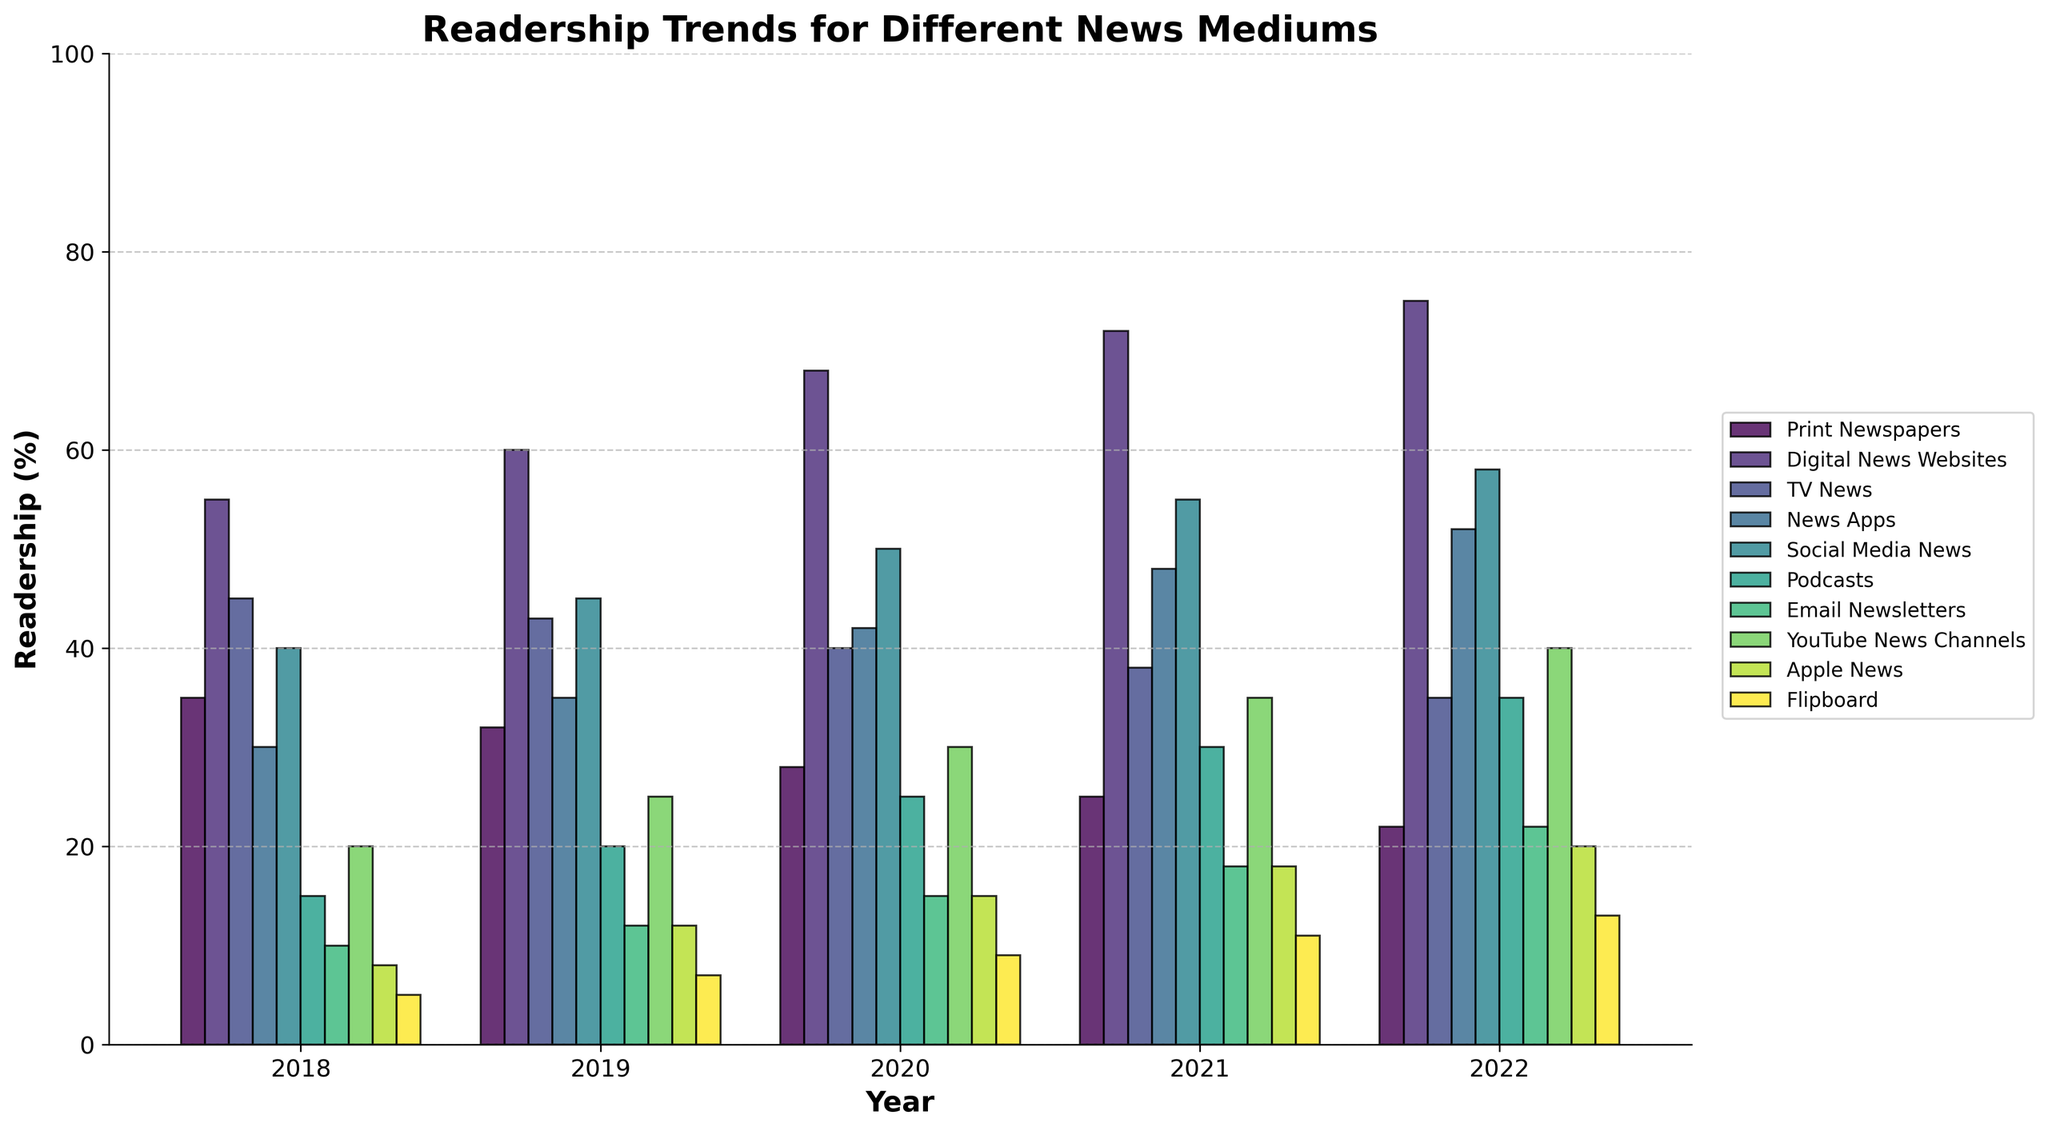What's the trend in readership of print newspapers from 2018 to 2022? The readership of print newspapers has been declining over the years. It was 35% in 2018, decreased to 32% in 2019, 28% in 2020, 25% in 2021, and finally 22% in 2022.
Answer: Declining Which medium had the highest readership in 2022? By observing the height of the bars in the year 2022, the digital news websites medium has the highest readership at 75%.
Answer: Digital News Websites How does the readership of TV news compare to podcasts in 2020? The bar for TV News in 2020 is at 40%, while the bar for Podcasts in 2020 is at 25%. Therefore, TV News has a higher readership than Podcasts in 2020.
Answer: TV News has higher readership What is the sum of the readership percentages for Digital News Websites and News Apps in 2021? The readership for Digital News Websites in 2021 is 72%, and for News Apps it is 48%. Summing them up gives 72% + 48% = 120%.
Answer: 120% What is the difference in the readership of Social Media News and Apple News in 2019? In 2019, Social Media News has a readership of 45%, and Apple News has 12%. The difference is 45% - 12% = 33%.
Answer: 33% Which medium saw the largest increase in readership between 2018 and 2022? The readership of News Apps increased from 30% in 2018 to 52% in 2022, an increase of 52% - 30% = 22%. By comparing all mediums, News Apps had the largest increase.
Answer: News Apps Between which years did YouTube News Channels see the highest growth in readership? YouTube News Channels grew from 20% in 2018 to 25% in 2019 (5% increase), from 25% in 2019 to 30% in 2020 (5% increase), from 30% in 2020 to 35% in 2021 (5% increase), and from 35% in 2021 to 40% in 2022 (5% increase). Since the growth was consistent at 5% each year, no single year stands out.
Answer: Consistent growth each year Compare the combined readership of Email Newsletters and Flipboard in 2021 with the readership of Print Newspapers in 2019. Combined readership of Email Newsletters (18%) and Flipboard (11%) in 2021 is 18% + 11% = 29%. The readership of Print Newspapers in 2019 is 32%. Therefore, the combined readership of Email Newsletters and Flipboard in 2021 is less.
Answer: Less What visual trend can be observed about the readership of TV News over the years? Visually, the bars representing TV News show a downward trend. They shrink in height from 2018 (45%) to 2022 (35%), indicating a decrease in readership.
Answer: Decreasing trend In 2020, which mediums had a readership of exactly 25%? By examining the height of the bars in 2020, both Podcasts and YouTube News Channels had a readership of 25%.
Answer: Podcasts and YouTube News Channels 